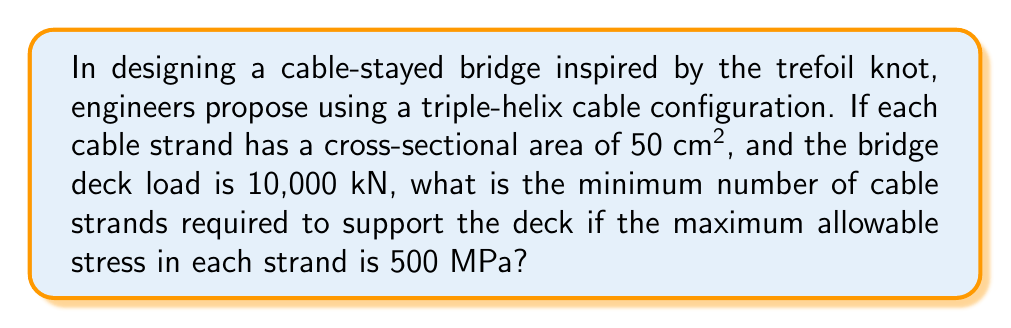Show me your answer to this math problem. To solve this problem, we'll follow these steps:

1. Convert units to ensure consistency:
   500 MPa = 500 × 10⁶ N/m² = 5 × 10⁸ N/m²

2. Calculate the cross-sectional area of each cable strand in m²:
   $A = 50 \text{ cm}^2 = 50 \times 10^{-4} \text{ m}^2 = 5 \times 10^{-3} \text{ m}^2$

3. Calculate the maximum force each cable strand can support:
   $F_{\text{max}} = \sigma A$
   Where $\sigma$ is the maximum allowable stress and $A$ is the cross-sectional area.
   
   $F_{\text{max}} = (5 \times 10^8 \text{ N/m}^2)(5 \times 10^{-3} \text{ m}^2) = 2.5 \times 10^6 \text{ N} = 2500 \text{ kN}$

4. Calculate the number of cable strands required:
   $n = \frac{\text{Total load}}{\text{Force per strand}} = \frac{10,000 \text{ kN}}{2500 \text{ kN}} = 4$

5. Since we can't have a fractional number of strands, we round up to the nearest whole number.

The trefoil knot inspiration suggests a triple-helix configuration, which inherently provides stability through its interlocking nature. This configuration distributes the load more evenly and reduces the risk of catastrophic failure, as the load is shared among multiple intertwined strands.
Answer: 4 cable strands 